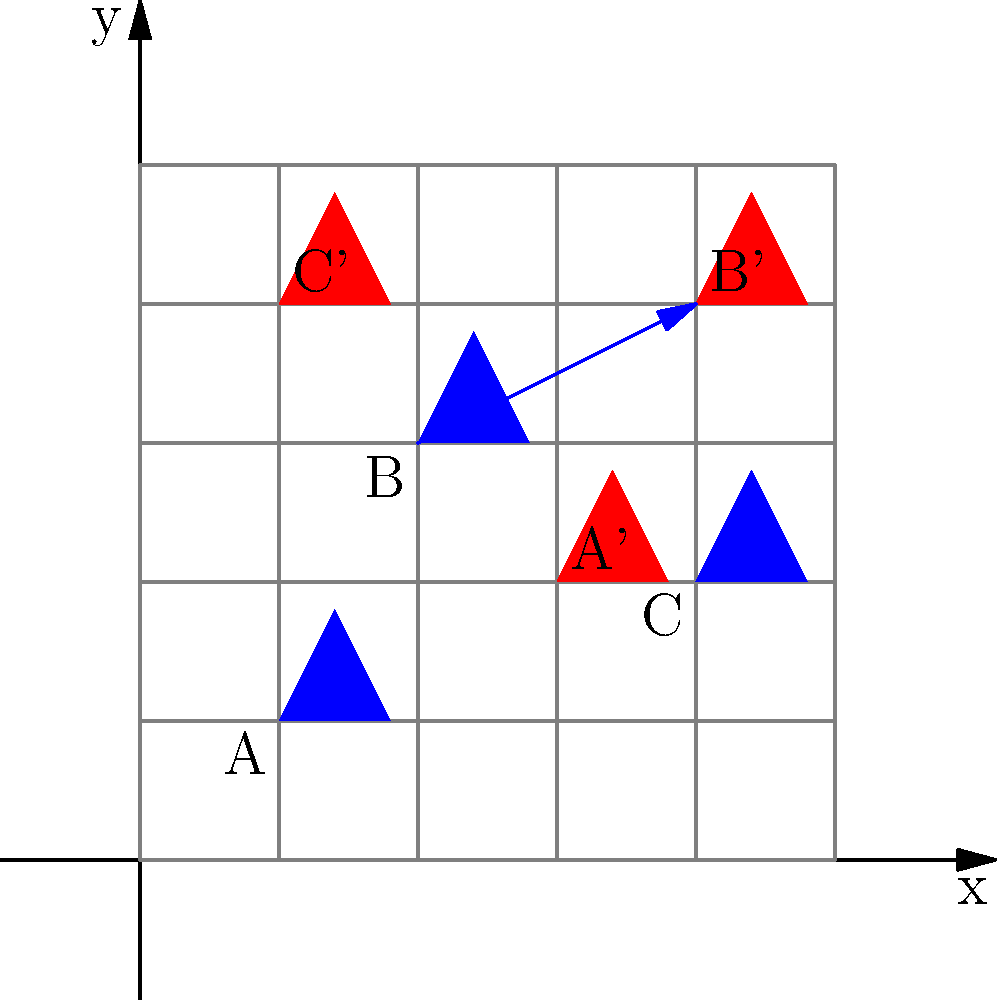In a study on workforce shifts due to automation, worker positions are represented on a coordinate plane. Blue icons show original positions, and red icons show new positions after automation-induced changes. If all workers are translated by the same vector, what is the translation vector that moves worker B to B'? To find the translation vector, we need to:

1. Identify the coordinates of point B (original position) and B' (new position):
   B: (2, 3)
   B': (4, 4)

2. Calculate the difference between the x-coordinates and y-coordinates:
   x-component: 4 - 2 = 2
   y-component: 4 - 3 = 1

3. Express the translation as a vector:
   The translation vector is $\vec{v} = \langle 2, 1 \rangle$

4. Verify that this translation works for the other points:
   A(1, 1) + $\langle 2, 1 \rangle$ = A'(3, 2)
   C(4, 2) + $\langle 2, 1 \rangle$ = C'(6, 3) (Note: C' is actually (1, 4), which suggests a wraparound effect on the x-axis)

The translation vector $\langle 2, 1 \rangle$ represents a shift of 2 units right and 1 unit up, symbolizing the workforce shift due to automation.
Answer: $\langle 2, 1 \rangle$ 